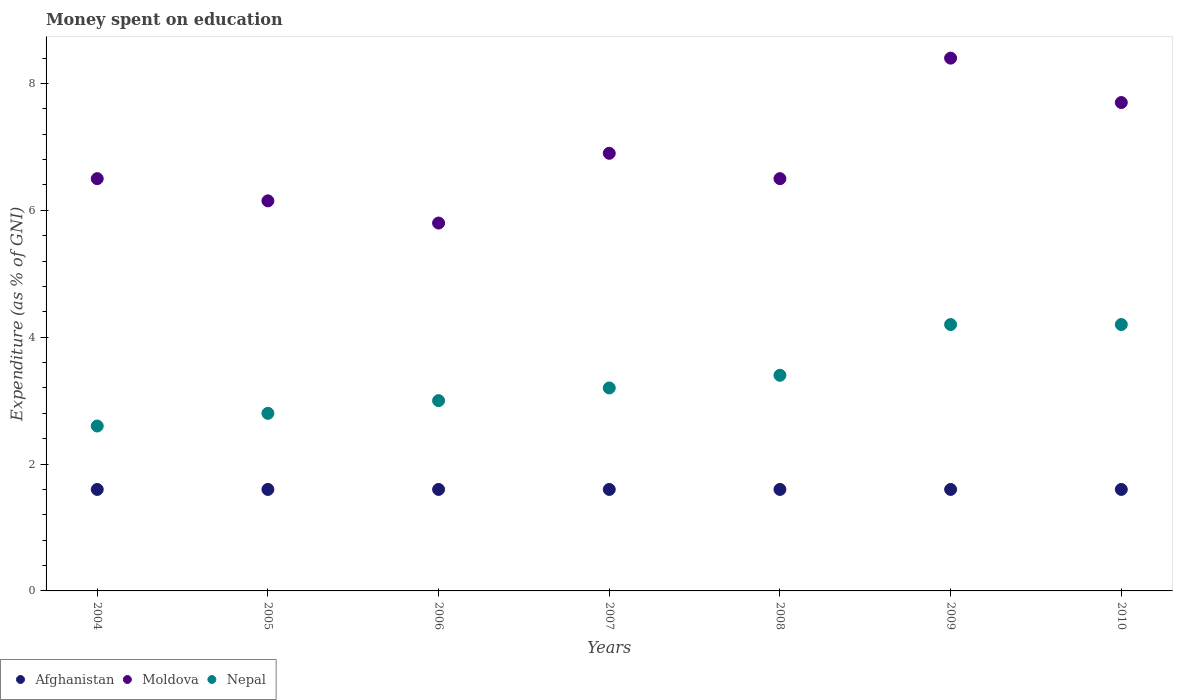How many different coloured dotlines are there?
Your response must be concise. 3. Is the number of dotlines equal to the number of legend labels?
Ensure brevity in your answer.  Yes. In which year was the amount of money spent on education in Nepal maximum?
Your response must be concise. 2009. What is the total amount of money spent on education in Afghanistan in the graph?
Provide a short and direct response. 11.2. What is the difference between the amount of money spent on education in Nepal in 2008 and that in 2010?
Keep it short and to the point. -0.8. What is the difference between the amount of money spent on education in Moldova in 2004 and the amount of money spent on education in Afghanistan in 2008?
Provide a short and direct response. 4.9. What is the average amount of money spent on education in Afghanistan per year?
Give a very brief answer. 1.6. In the year 2009, what is the difference between the amount of money spent on education in Moldova and amount of money spent on education in Afghanistan?
Keep it short and to the point. 6.8. What is the ratio of the amount of money spent on education in Nepal in 2006 to that in 2008?
Ensure brevity in your answer.  0.88. Is the difference between the amount of money spent on education in Moldova in 2004 and 2008 greater than the difference between the amount of money spent on education in Afghanistan in 2004 and 2008?
Provide a succinct answer. No. What is the difference between the highest and the lowest amount of money spent on education in Moldova?
Give a very brief answer. 2.6. In how many years, is the amount of money spent on education in Nepal greater than the average amount of money spent on education in Nepal taken over all years?
Give a very brief answer. 3. Is the sum of the amount of money spent on education in Moldova in 2008 and 2010 greater than the maximum amount of money spent on education in Nepal across all years?
Your answer should be very brief. Yes. How many dotlines are there?
Your answer should be very brief. 3. Are the values on the major ticks of Y-axis written in scientific E-notation?
Offer a very short reply. No. Does the graph contain any zero values?
Offer a very short reply. No. How many legend labels are there?
Give a very brief answer. 3. What is the title of the graph?
Your answer should be compact. Money spent on education. What is the label or title of the Y-axis?
Keep it short and to the point. Expenditure (as % of GNI). What is the Expenditure (as % of GNI) of Moldova in 2004?
Provide a succinct answer. 6.5. What is the Expenditure (as % of GNI) of Nepal in 2004?
Give a very brief answer. 2.6. What is the Expenditure (as % of GNI) in Afghanistan in 2005?
Your answer should be very brief. 1.6. What is the Expenditure (as % of GNI) of Moldova in 2005?
Ensure brevity in your answer.  6.15. What is the Expenditure (as % of GNI) in Nepal in 2005?
Offer a very short reply. 2.8. What is the Expenditure (as % of GNI) in Afghanistan in 2006?
Your answer should be compact. 1.6. What is the Expenditure (as % of GNI) in Nepal in 2006?
Provide a short and direct response. 3. What is the Expenditure (as % of GNI) of Moldova in 2007?
Ensure brevity in your answer.  6.9. What is the Expenditure (as % of GNI) in Nepal in 2007?
Provide a succinct answer. 3.2. What is the Expenditure (as % of GNI) of Moldova in 2009?
Ensure brevity in your answer.  8.4. What is the Expenditure (as % of GNI) of Afghanistan in 2010?
Ensure brevity in your answer.  1.6. What is the Expenditure (as % of GNI) in Moldova in 2010?
Your answer should be very brief. 7.7. What is the Expenditure (as % of GNI) of Nepal in 2010?
Ensure brevity in your answer.  4.2. Across all years, what is the maximum Expenditure (as % of GNI) of Moldova?
Your response must be concise. 8.4. Across all years, what is the maximum Expenditure (as % of GNI) of Nepal?
Give a very brief answer. 4.2. Across all years, what is the minimum Expenditure (as % of GNI) in Moldova?
Keep it short and to the point. 5.8. Across all years, what is the minimum Expenditure (as % of GNI) of Nepal?
Your answer should be compact. 2.6. What is the total Expenditure (as % of GNI) of Moldova in the graph?
Offer a terse response. 47.95. What is the total Expenditure (as % of GNI) of Nepal in the graph?
Provide a short and direct response. 23.4. What is the difference between the Expenditure (as % of GNI) of Moldova in 2004 and that in 2005?
Keep it short and to the point. 0.35. What is the difference between the Expenditure (as % of GNI) in Nepal in 2004 and that in 2005?
Provide a succinct answer. -0.2. What is the difference between the Expenditure (as % of GNI) of Afghanistan in 2004 and that in 2006?
Ensure brevity in your answer.  0. What is the difference between the Expenditure (as % of GNI) of Nepal in 2004 and that in 2006?
Provide a short and direct response. -0.4. What is the difference between the Expenditure (as % of GNI) in Afghanistan in 2004 and that in 2007?
Your answer should be compact. 0. What is the difference between the Expenditure (as % of GNI) in Nepal in 2004 and that in 2008?
Give a very brief answer. -0.8. What is the difference between the Expenditure (as % of GNI) in Afghanistan in 2004 and that in 2009?
Give a very brief answer. 0. What is the difference between the Expenditure (as % of GNI) in Nepal in 2004 and that in 2009?
Provide a succinct answer. -1.6. What is the difference between the Expenditure (as % of GNI) in Moldova in 2004 and that in 2010?
Offer a terse response. -1.2. What is the difference between the Expenditure (as % of GNI) of Nepal in 2005 and that in 2006?
Make the answer very short. -0.2. What is the difference between the Expenditure (as % of GNI) in Moldova in 2005 and that in 2007?
Keep it short and to the point. -0.75. What is the difference between the Expenditure (as % of GNI) of Moldova in 2005 and that in 2008?
Give a very brief answer. -0.35. What is the difference between the Expenditure (as % of GNI) in Nepal in 2005 and that in 2008?
Offer a terse response. -0.6. What is the difference between the Expenditure (as % of GNI) in Afghanistan in 2005 and that in 2009?
Offer a very short reply. 0. What is the difference between the Expenditure (as % of GNI) of Moldova in 2005 and that in 2009?
Provide a succinct answer. -2.25. What is the difference between the Expenditure (as % of GNI) of Moldova in 2005 and that in 2010?
Offer a terse response. -1.55. What is the difference between the Expenditure (as % of GNI) of Nepal in 2005 and that in 2010?
Your answer should be very brief. -1.4. What is the difference between the Expenditure (as % of GNI) of Moldova in 2006 and that in 2007?
Offer a terse response. -1.1. What is the difference between the Expenditure (as % of GNI) in Afghanistan in 2006 and that in 2008?
Offer a very short reply. 0. What is the difference between the Expenditure (as % of GNI) in Afghanistan in 2006 and that in 2009?
Provide a succinct answer. 0. What is the difference between the Expenditure (as % of GNI) in Nepal in 2006 and that in 2009?
Give a very brief answer. -1.2. What is the difference between the Expenditure (as % of GNI) in Afghanistan in 2006 and that in 2010?
Keep it short and to the point. 0. What is the difference between the Expenditure (as % of GNI) of Moldova in 2006 and that in 2010?
Ensure brevity in your answer.  -1.9. What is the difference between the Expenditure (as % of GNI) of Nepal in 2006 and that in 2010?
Make the answer very short. -1.2. What is the difference between the Expenditure (as % of GNI) of Afghanistan in 2007 and that in 2008?
Your answer should be compact. 0. What is the difference between the Expenditure (as % of GNI) in Nepal in 2007 and that in 2009?
Offer a very short reply. -1. What is the difference between the Expenditure (as % of GNI) of Moldova in 2007 and that in 2010?
Your answer should be very brief. -0.8. What is the difference between the Expenditure (as % of GNI) in Afghanistan in 2008 and that in 2009?
Offer a very short reply. 0. What is the difference between the Expenditure (as % of GNI) of Nepal in 2008 and that in 2009?
Provide a short and direct response. -0.8. What is the difference between the Expenditure (as % of GNI) of Nepal in 2008 and that in 2010?
Make the answer very short. -0.8. What is the difference between the Expenditure (as % of GNI) in Afghanistan in 2009 and that in 2010?
Ensure brevity in your answer.  0. What is the difference between the Expenditure (as % of GNI) in Moldova in 2009 and that in 2010?
Offer a very short reply. 0.7. What is the difference between the Expenditure (as % of GNI) of Nepal in 2009 and that in 2010?
Make the answer very short. 0. What is the difference between the Expenditure (as % of GNI) of Afghanistan in 2004 and the Expenditure (as % of GNI) of Moldova in 2005?
Give a very brief answer. -4.55. What is the difference between the Expenditure (as % of GNI) of Afghanistan in 2004 and the Expenditure (as % of GNI) of Nepal in 2006?
Offer a very short reply. -1.4. What is the difference between the Expenditure (as % of GNI) in Afghanistan in 2004 and the Expenditure (as % of GNI) in Moldova in 2007?
Keep it short and to the point. -5.3. What is the difference between the Expenditure (as % of GNI) of Moldova in 2004 and the Expenditure (as % of GNI) of Nepal in 2008?
Give a very brief answer. 3.1. What is the difference between the Expenditure (as % of GNI) of Afghanistan in 2004 and the Expenditure (as % of GNI) of Nepal in 2009?
Give a very brief answer. -2.6. What is the difference between the Expenditure (as % of GNI) in Afghanistan in 2004 and the Expenditure (as % of GNI) in Moldova in 2010?
Keep it short and to the point. -6.1. What is the difference between the Expenditure (as % of GNI) in Moldova in 2005 and the Expenditure (as % of GNI) in Nepal in 2006?
Offer a very short reply. 3.15. What is the difference between the Expenditure (as % of GNI) in Afghanistan in 2005 and the Expenditure (as % of GNI) in Moldova in 2007?
Make the answer very short. -5.3. What is the difference between the Expenditure (as % of GNI) of Afghanistan in 2005 and the Expenditure (as % of GNI) of Nepal in 2007?
Provide a succinct answer. -1.6. What is the difference between the Expenditure (as % of GNI) of Moldova in 2005 and the Expenditure (as % of GNI) of Nepal in 2007?
Your answer should be compact. 2.95. What is the difference between the Expenditure (as % of GNI) of Afghanistan in 2005 and the Expenditure (as % of GNI) of Moldova in 2008?
Offer a terse response. -4.9. What is the difference between the Expenditure (as % of GNI) in Moldova in 2005 and the Expenditure (as % of GNI) in Nepal in 2008?
Your answer should be very brief. 2.75. What is the difference between the Expenditure (as % of GNI) in Afghanistan in 2005 and the Expenditure (as % of GNI) in Moldova in 2009?
Make the answer very short. -6.8. What is the difference between the Expenditure (as % of GNI) of Afghanistan in 2005 and the Expenditure (as % of GNI) of Nepal in 2009?
Your response must be concise. -2.6. What is the difference between the Expenditure (as % of GNI) in Moldova in 2005 and the Expenditure (as % of GNI) in Nepal in 2009?
Your answer should be very brief. 1.95. What is the difference between the Expenditure (as % of GNI) of Afghanistan in 2005 and the Expenditure (as % of GNI) of Nepal in 2010?
Offer a terse response. -2.6. What is the difference between the Expenditure (as % of GNI) of Moldova in 2005 and the Expenditure (as % of GNI) of Nepal in 2010?
Your answer should be compact. 1.95. What is the difference between the Expenditure (as % of GNI) in Afghanistan in 2006 and the Expenditure (as % of GNI) in Moldova in 2008?
Make the answer very short. -4.9. What is the difference between the Expenditure (as % of GNI) in Afghanistan in 2006 and the Expenditure (as % of GNI) in Nepal in 2008?
Provide a succinct answer. -1.8. What is the difference between the Expenditure (as % of GNI) of Moldova in 2006 and the Expenditure (as % of GNI) of Nepal in 2008?
Offer a very short reply. 2.4. What is the difference between the Expenditure (as % of GNI) in Afghanistan in 2006 and the Expenditure (as % of GNI) in Moldova in 2009?
Your response must be concise. -6.8. What is the difference between the Expenditure (as % of GNI) in Afghanistan in 2006 and the Expenditure (as % of GNI) in Nepal in 2009?
Provide a short and direct response. -2.6. What is the difference between the Expenditure (as % of GNI) in Afghanistan in 2006 and the Expenditure (as % of GNI) in Moldova in 2010?
Provide a succinct answer. -6.1. What is the difference between the Expenditure (as % of GNI) of Moldova in 2007 and the Expenditure (as % of GNI) of Nepal in 2008?
Give a very brief answer. 3.5. What is the difference between the Expenditure (as % of GNI) in Afghanistan in 2007 and the Expenditure (as % of GNI) in Moldova in 2009?
Provide a succinct answer. -6.8. What is the difference between the Expenditure (as % of GNI) in Afghanistan in 2007 and the Expenditure (as % of GNI) in Nepal in 2009?
Your answer should be compact. -2.6. What is the difference between the Expenditure (as % of GNI) of Afghanistan in 2008 and the Expenditure (as % of GNI) of Moldova in 2009?
Your answer should be very brief. -6.8. What is the difference between the Expenditure (as % of GNI) in Afghanistan in 2008 and the Expenditure (as % of GNI) in Moldova in 2010?
Offer a terse response. -6.1. What is the difference between the Expenditure (as % of GNI) in Afghanistan in 2009 and the Expenditure (as % of GNI) in Moldova in 2010?
Your answer should be very brief. -6.1. What is the difference between the Expenditure (as % of GNI) in Afghanistan in 2009 and the Expenditure (as % of GNI) in Nepal in 2010?
Your answer should be compact. -2.6. What is the average Expenditure (as % of GNI) in Afghanistan per year?
Ensure brevity in your answer.  1.6. What is the average Expenditure (as % of GNI) of Moldova per year?
Your response must be concise. 6.85. What is the average Expenditure (as % of GNI) in Nepal per year?
Ensure brevity in your answer.  3.34. In the year 2004, what is the difference between the Expenditure (as % of GNI) of Afghanistan and Expenditure (as % of GNI) of Nepal?
Provide a short and direct response. -1. In the year 2004, what is the difference between the Expenditure (as % of GNI) of Moldova and Expenditure (as % of GNI) of Nepal?
Give a very brief answer. 3.9. In the year 2005, what is the difference between the Expenditure (as % of GNI) of Afghanistan and Expenditure (as % of GNI) of Moldova?
Your answer should be compact. -4.55. In the year 2005, what is the difference between the Expenditure (as % of GNI) in Afghanistan and Expenditure (as % of GNI) in Nepal?
Give a very brief answer. -1.2. In the year 2005, what is the difference between the Expenditure (as % of GNI) in Moldova and Expenditure (as % of GNI) in Nepal?
Keep it short and to the point. 3.35. In the year 2006, what is the difference between the Expenditure (as % of GNI) of Afghanistan and Expenditure (as % of GNI) of Nepal?
Your answer should be compact. -1.4. In the year 2007, what is the difference between the Expenditure (as % of GNI) of Moldova and Expenditure (as % of GNI) of Nepal?
Your answer should be very brief. 3.7. In the year 2008, what is the difference between the Expenditure (as % of GNI) in Afghanistan and Expenditure (as % of GNI) in Moldova?
Provide a succinct answer. -4.9. In the year 2009, what is the difference between the Expenditure (as % of GNI) of Afghanistan and Expenditure (as % of GNI) of Moldova?
Your response must be concise. -6.8. In the year 2009, what is the difference between the Expenditure (as % of GNI) of Afghanistan and Expenditure (as % of GNI) of Nepal?
Offer a very short reply. -2.6. In the year 2009, what is the difference between the Expenditure (as % of GNI) of Moldova and Expenditure (as % of GNI) of Nepal?
Provide a succinct answer. 4.2. In the year 2010, what is the difference between the Expenditure (as % of GNI) in Afghanistan and Expenditure (as % of GNI) in Moldova?
Give a very brief answer. -6.1. In the year 2010, what is the difference between the Expenditure (as % of GNI) of Moldova and Expenditure (as % of GNI) of Nepal?
Ensure brevity in your answer.  3.5. What is the ratio of the Expenditure (as % of GNI) in Moldova in 2004 to that in 2005?
Keep it short and to the point. 1.06. What is the ratio of the Expenditure (as % of GNI) in Nepal in 2004 to that in 2005?
Give a very brief answer. 0.93. What is the ratio of the Expenditure (as % of GNI) of Moldova in 2004 to that in 2006?
Make the answer very short. 1.12. What is the ratio of the Expenditure (as % of GNI) in Nepal in 2004 to that in 2006?
Provide a short and direct response. 0.87. What is the ratio of the Expenditure (as % of GNI) in Afghanistan in 2004 to that in 2007?
Provide a short and direct response. 1. What is the ratio of the Expenditure (as % of GNI) in Moldova in 2004 to that in 2007?
Ensure brevity in your answer.  0.94. What is the ratio of the Expenditure (as % of GNI) in Nepal in 2004 to that in 2007?
Offer a terse response. 0.81. What is the ratio of the Expenditure (as % of GNI) of Afghanistan in 2004 to that in 2008?
Keep it short and to the point. 1. What is the ratio of the Expenditure (as % of GNI) in Nepal in 2004 to that in 2008?
Keep it short and to the point. 0.76. What is the ratio of the Expenditure (as % of GNI) of Afghanistan in 2004 to that in 2009?
Keep it short and to the point. 1. What is the ratio of the Expenditure (as % of GNI) of Moldova in 2004 to that in 2009?
Offer a terse response. 0.77. What is the ratio of the Expenditure (as % of GNI) of Nepal in 2004 to that in 2009?
Provide a short and direct response. 0.62. What is the ratio of the Expenditure (as % of GNI) of Afghanistan in 2004 to that in 2010?
Ensure brevity in your answer.  1. What is the ratio of the Expenditure (as % of GNI) of Moldova in 2004 to that in 2010?
Your response must be concise. 0.84. What is the ratio of the Expenditure (as % of GNI) of Nepal in 2004 to that in 2010?
Give a very brief answer. 0.62. What is the ratio of the Expenditure (as % of GNI) in Moldova in 2005 to that in 2006?
Ensure brevity in your answer.  1.06. What is the ratio of the Expenditure (as % of GNI) of Nepal in 2005 to that in 2006?
Provide a succinct answer. 0.93. What is the ratio of the Expenditure (as % of GNI) of Moldova in 2005 to that in 2007?
Your answer should be very brief. 0.89. What is the ratio of the Expenditure (as % of GNI) of Nepal in 2005 to that in 2007?
Make the answer very short. 0.88. What is the ratio of the Expenditure (as % of GNI) of Moldova in 2005 to that in 2008?
Your response must be concise. 0.95. What is the ratio of the Expenditure (as % of GNI) of Nepal in 2005 to that in 2008?
Ensure brevity in your answer.  0.82. What is the ratio of the Expenditure (as % of GNI) in Moldova in 2005 to that in 2009?
Keep it short and to the point. 0.73. What is the ratio of the Expenditure (as % of GNI) of Nepal in 2005 to that in 2009?
Your answer should be very brief. 0.67. What is the ratio of the Expenditure (as % of GNI) of Afghanistan in 2005 to that in 2010?
Offer a terse response. 1. What is the ratio of the Expenditure (as % of GNI) in Moldova in 2005 to that in 2010?
Make the answer very short. 0.8. What is the ratio of the Expenditure (as % of GNI) in Nepal in 2005 to that in 2010?
Your answer should be compact. 0.67. What is the ratio of the Expenditure (as % of GNI) in Afghanistan in 2006 to that in 2007?
Ensure brevity in your answer.  1. What is the ratio of the Expenditure (as % of GNI) of Moldova in 2006 to that in 2007?
Your answer should be very brief. 0.84. What is the ratio of the Expenditure (as % of GNI) of Afghanistan in 2006 to that in 2008?
Offer a terse response. 1. What is the ratio of the Expenditure (as % of GNI) of Moldova in 2006 to that in 2008?
Make the answer very short. 0.89. What is the ratio of the Expenditure (as % of GNI) in Nepal in 2006 to that in 2008?
Offer a very short reply. 0.88. What is the ratio of the Expenditure (as % of GNI) of Moldova in 2006 to that in 2009?
Your response must be concise. 0.69. What is the ratio of the Expenditure (as % of GNI) in Moldova in 2006 to that in 2010?
Ensure brevity in your answer.  0.75. What is the ratio of the Expenditure (as % of GNI) of Nepal in 2006 to that in 2010?
Your response must be concise. 0.71. What is the ratio of the Expenditure (as % of GNI) of Afghanistan in 2007 to that in 2008?
Make the answer very short. 1. What is the ratio of the Expenditure (as % of GNI) of Moldova in 2007 to that in 2008?
Ensure brevity in your answer.  1.06. What is the ratio of the Expenditure (as % of GNI) in Afghanistan in 2007 to that in 2009?
Provide a succinct answer. 1. What is the ratio of the Expenditure (as % of GNI) of Moldova in 2007 to that in 2009?
Keep it short and to the point. 0.82. What is the ratio of the Expenditure (as % of GNI) of Nepal in 2007 to that in 2009?
Give a very brief answer. 0.76. What is the ratio of the Expenditure (as % of GNI) in Moldova in 2007 to that in 2010?
Your answer should be very brief. 0.9. What is the ratio of the Expenditure (as % of GNI) in Nepal in 2007 to that in 2010?
Ensure brevity in your answer.  0.76. What is the ratio of the Expenditure (as % of GNI) in Moldova in 2008 to that in 2009?
Offer a terse response. 0.77. What is the ratio of the Expenditure (as % of GNI) of Nepal in 2008 to that in 2009?
Provide a succinct answer. 0.81. What is the ratio of the Expenditure (as % of GNI) of Moldova in 2008 to that in 2010?
Offer a terse response. 0.84. What is the ratio of the Expenditure (as % of GNI) in Nepal in 2008 to that in 2010?
Provide a short and direct response. 0.81. What is the ratio of the Expenditure (as % of GNI) in Nepal in 2009 to that in 2010?
Make the answer very short. 1. What is the difference between the highest and the second highest Expenditure (as % of GNI) in Afghanistan?
Give a very brief answer. 0. What is the difference between the highest and the second highest Expenditure (as % of GNI) of Moldova?
Provide a short and direct response. 0.7. What is the difference between the highest and the lowest Expenditure (as % of GNI) of Afghanistan?
Provide a succinct answer. 0. 